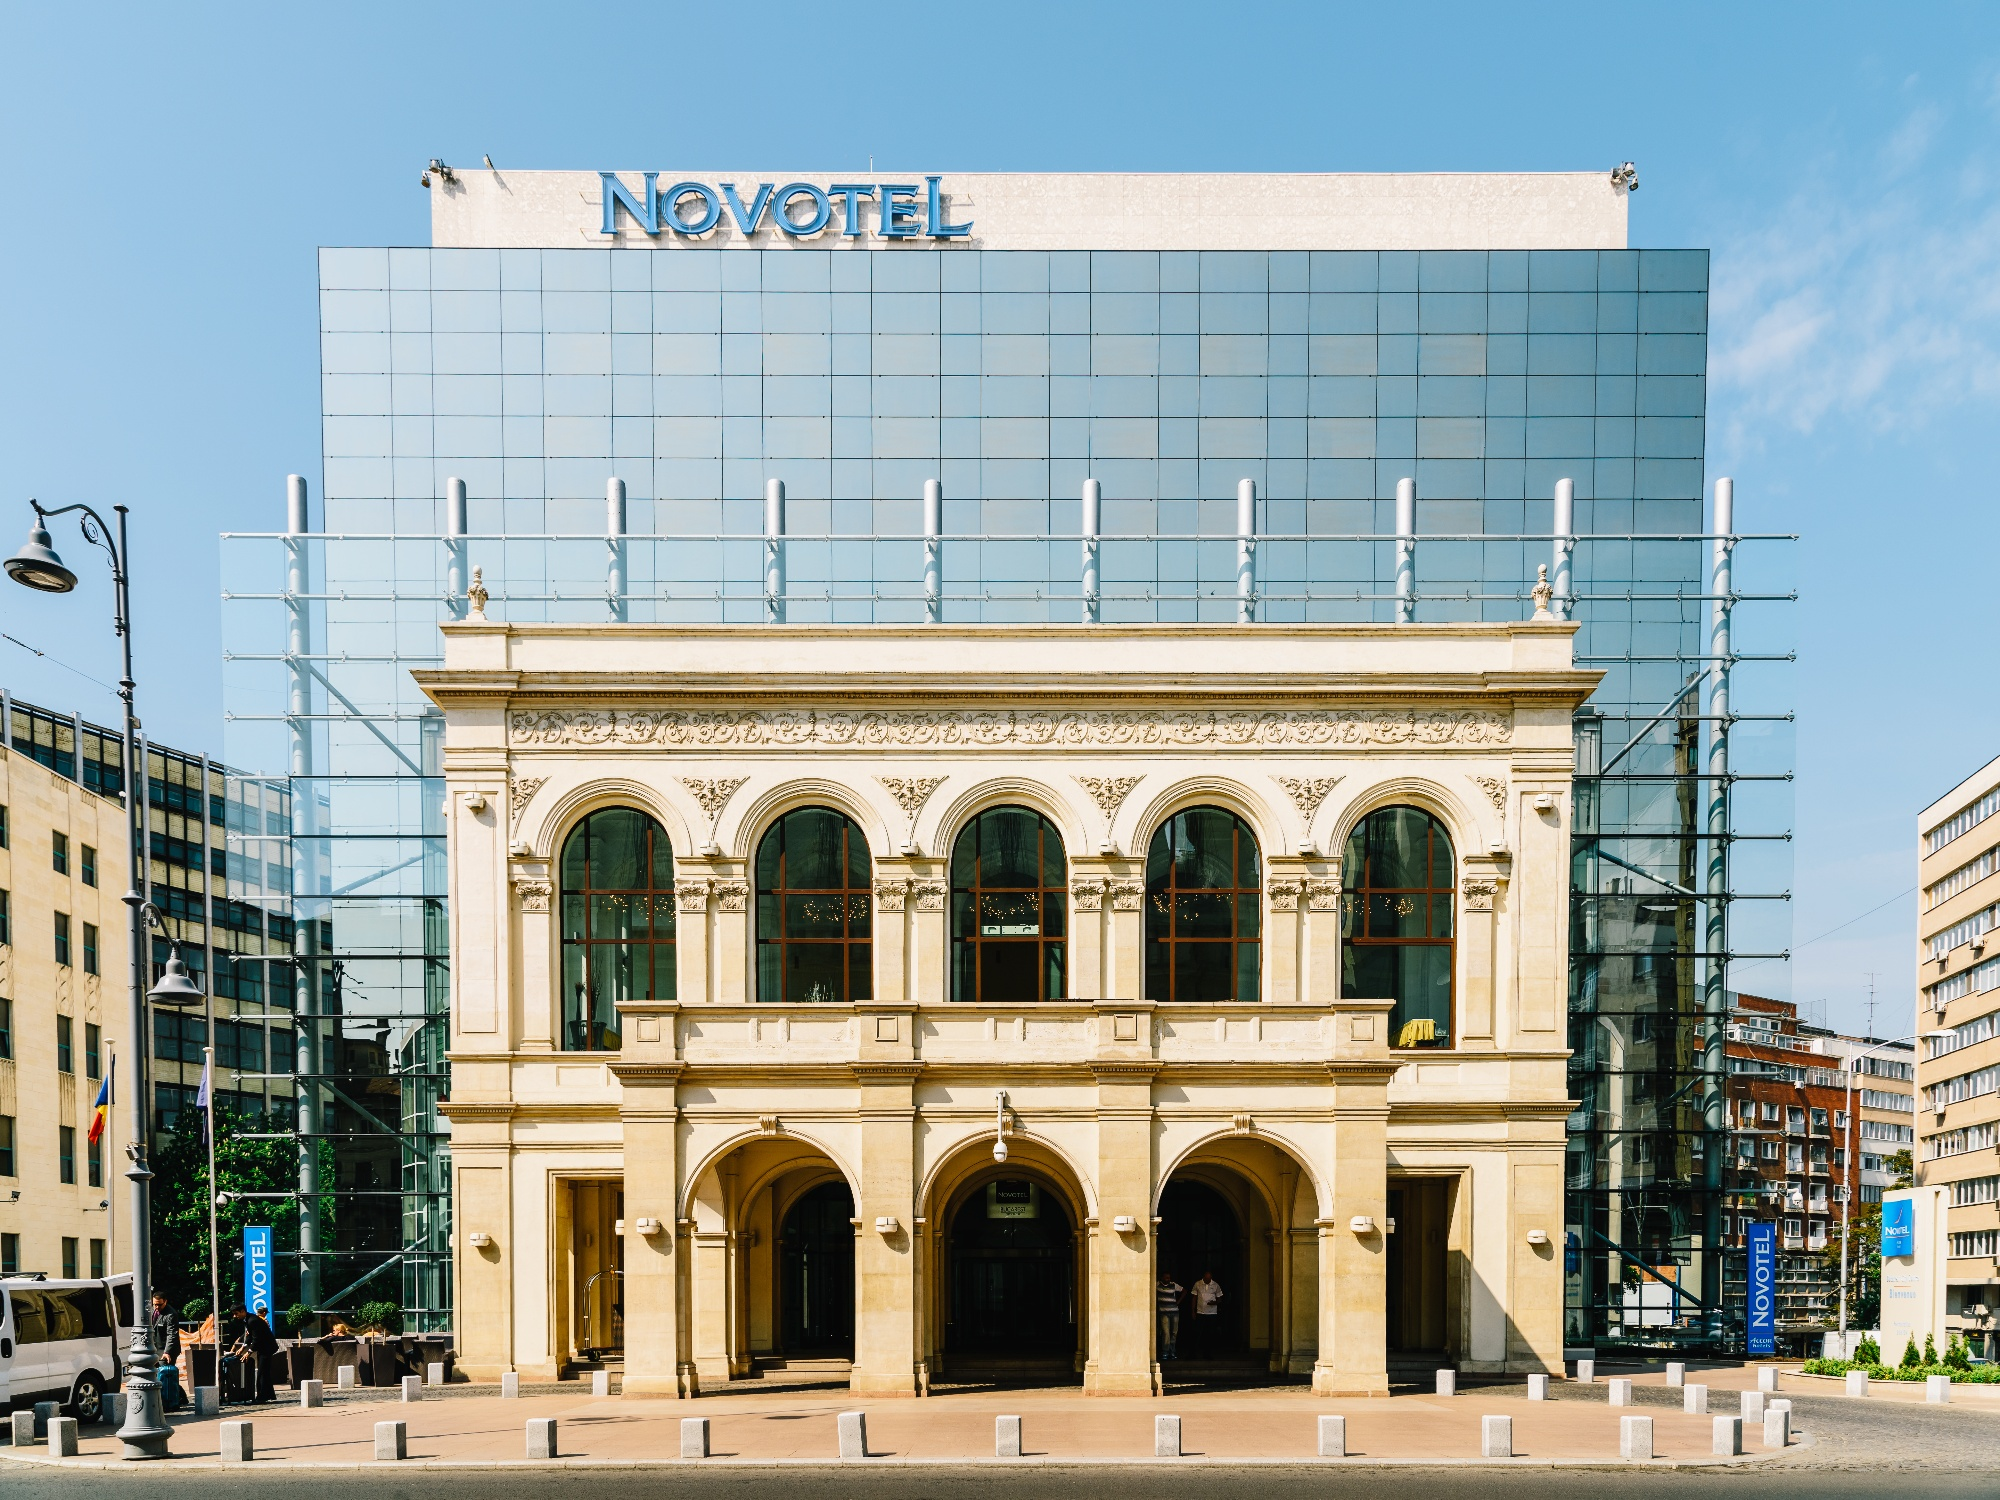Explain the visual content of the image in great detail.
 The image captures the Novotel Hotel in Warsaw, Poland. The hotel is a striking blend of old and new architectural styles. The modern upper part of the building is characterized by a glass facade that reflects the clear blue sky. A large blue sign at the top proudly displays the name of the hotel. The building is currently surrounded by scaffolding, suggesting ongoing maintenance or construction work. 

In contrast, the lower part of the building retains an older, more ornate structure. It features arched windows and doorways that add a touch of elegance and history to the overall appearance of the hotel. The photo is taken from a street-level perspective, giving us a comprehensive view of the hotel against the backdrop of a clear blue sky. The identifier "sa_14628" doesn't provide additional information about the landmark. 